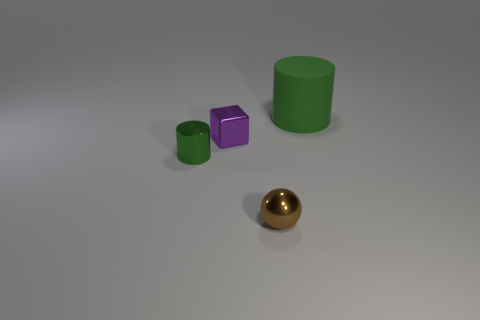Add 3 tiny metallic objects. How many objects exist? 7 Subtract all spheres. How many objects are left? 3 Add 1 small brown shiny spheres. How many small brown shiny spheres are left? 2 Add 3 small blocks. How many small blocks exist? 4 Subtract 0 red blocks. How many objects are left? 4 Subtract all large matte balls. Subtract all small purple cubes. How many objects are left? 3 